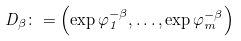<formula> <loc_0><loc_0><loc_500><loc_500>D _ { \beta } \colon = \left ( \exp \varphi _ { 1 } ^ { - \beta } , \dots , \exp \varphi _ { m } ^ { - \beta } \right )</formula> 